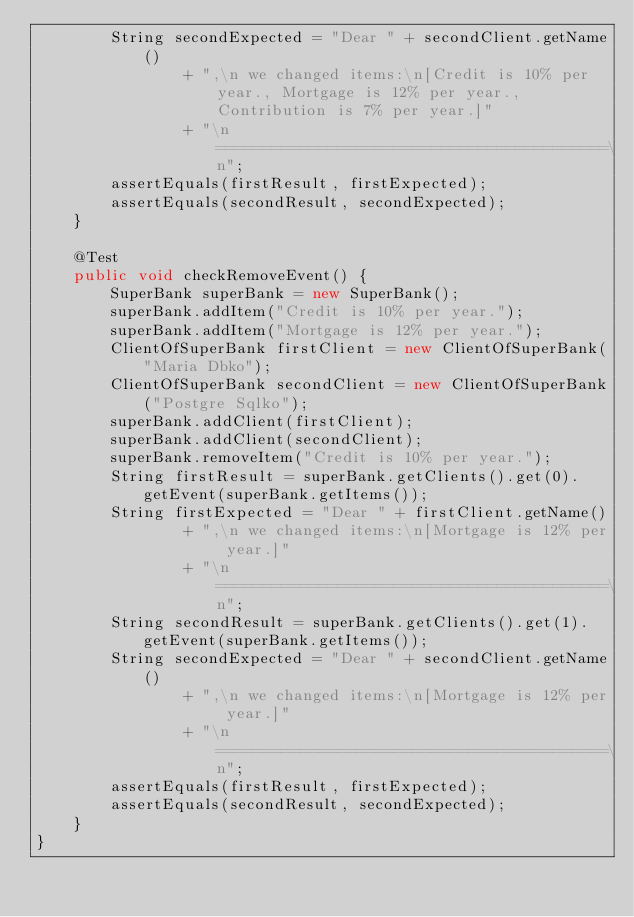Convert code to text. <code><loc_0><loc_0><loc_500><loc_500><_Java_>        String secondExpected = "Dear " + secondClient.getName()
                + ",\n we changed items:\n[Credit is 10% per year., Mortgage is 12% per year., Contribution is 7% per year.]"
                + "\n==========================================\n";
        assertEquals(firstResult, firstExpected);
        assertEquals(secondResult, secondExpected);
    }

    @Test
    public void checkRemoveEvent() {
        SuperBank superBank = new SuperBank();
        superBank.addItem("Credit is 10% per year.");
        superBank.addItem("Mortgage is 12% per year.");
        ClientOfSuperBank firstClient = new ClientOfSuperBank("Maria Dbko");
        ClientOfSuperBank secondClient = new ClientOfSuperBank("Postgre Sqlko");
        superBank.addClient(firstClient);
        superBank.addClient(secondClient);
        superBank.removeItem("Credit is 10% per year.");
        String firstResult = superBank.getClients().get(0).getEvent(superBank.getItems());
        String firstExpected = "Dear " + firstClient.getName()
                + ",\n we changed items:\n[Mortgage is 12% per year.]"
                + "\n==========================================\n";
        String secondResult = superBank.getClients().get(1).getEvent(superBank.getItems());
        String secondExpected = "Dear " + secondClient.getName()
                + ",\n we changed items:\n[Mortgage is 12% per year.]"
                + "\n==========================================\n";
        assertEquals(firstResult, firstExpected);
        assertEquals(secondResult, secondExpected);
    }
}
</code> 